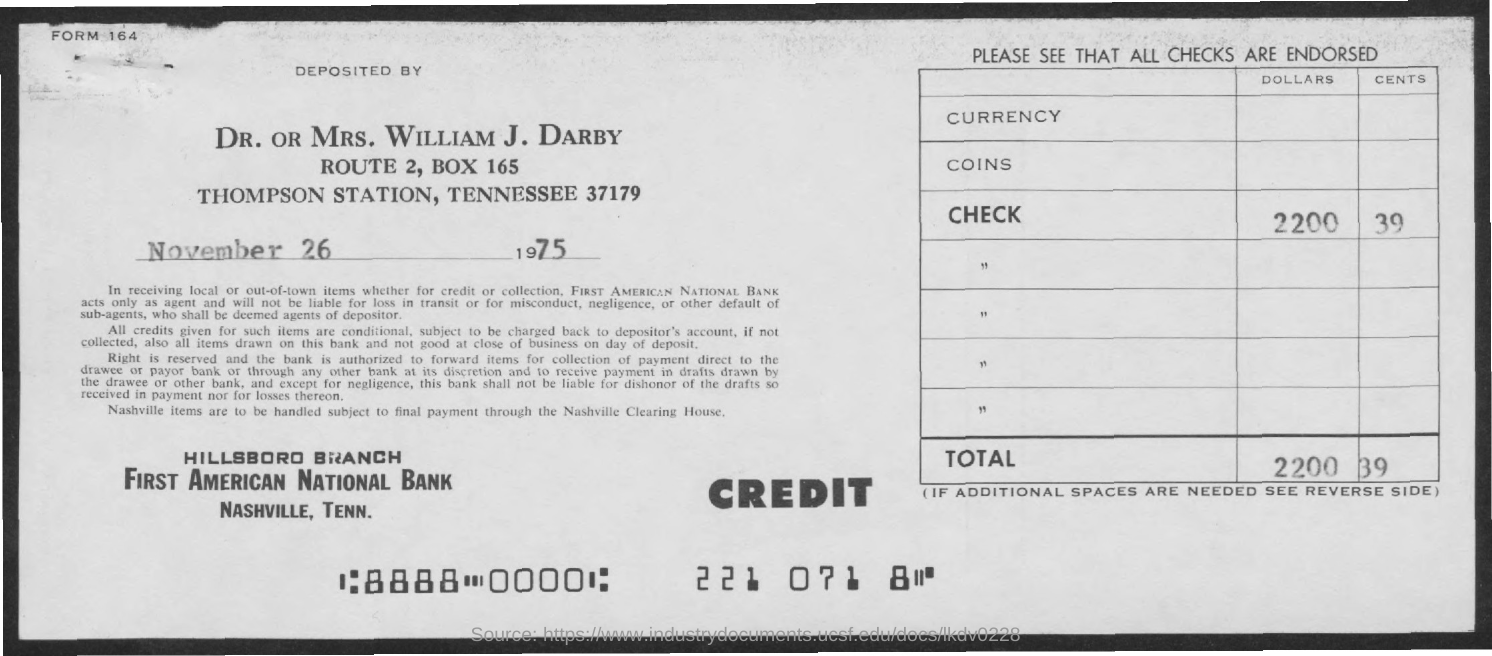Outline some significant characteristics in this image. The total amount is 2200.39 and... The check amount is 2,200.39. The document indicates that the date is November 26, 1975. 